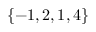Convert formula to latex. <formula><loc_0><loc_0><loc_500><loc_500>\{ - 1 , 2 , 1 , 4 \}</formula> 